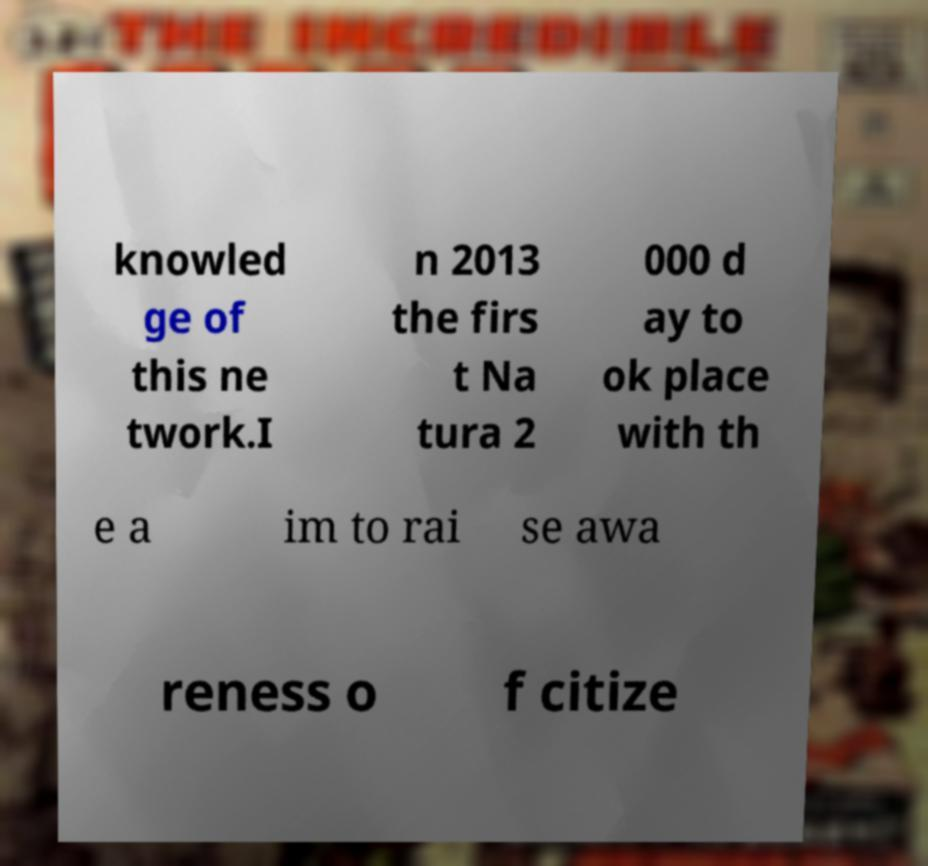There's text embedded in this image that I need extracted. Can you transcribe it verbatim? knowled ge of this ne twork.I n 2013 the firs t Na tura 2 000 d ay to ok place with th e a im to rai se awa reness o f citize 